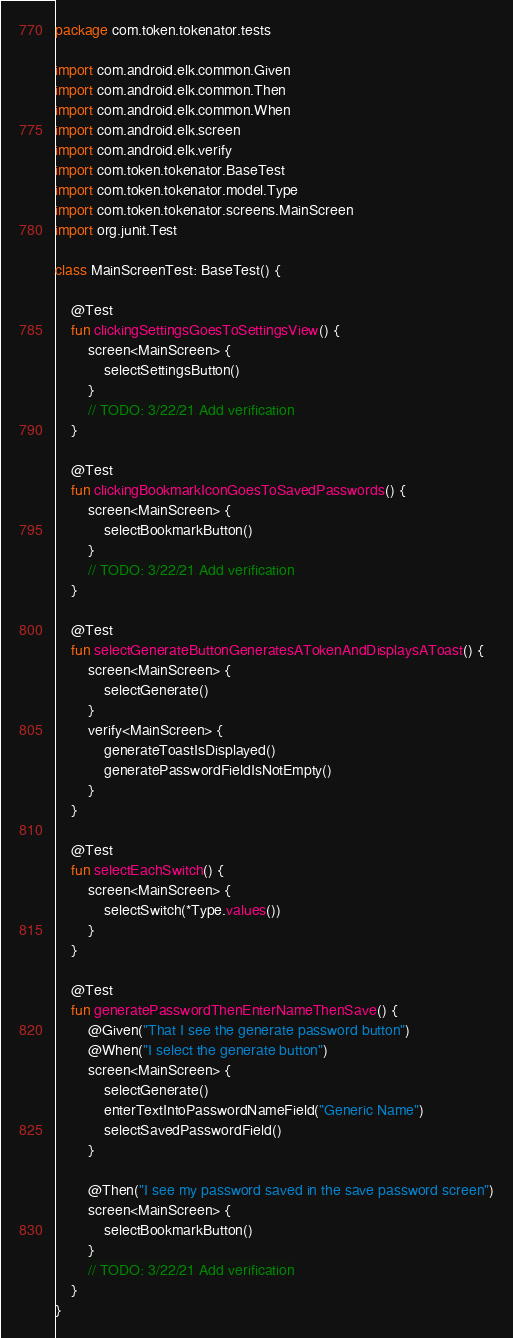Convert code to text. <code><loc_0><loc_0><loc_500><loc_500><_Kotlin_>package com.token.tokenator.tests

import com.android.elk.common.Given
import com.android.elk.common.Then
import com.android.elk.common.When
import com.android.elk.screen
import com.android.elk.verify
import com.token.tokenator.BaseTest
import com.token.tokenator.model.Type
import com.token.tokenator.screens.MainScreen
import org.junit.Test

class MainScreenTest: BaseTest() {

    @Test
    fun clickingSettingsGoesToSettingsView() {
        screen<MainScreen> {
            selectSettingsButton()
        }
        // TODO: 3/22/21 Add verification
    }

    @Test
    fun clickingBookmarkIconGoesToSavedPasswords() {
        screen<MainScreen> {
            selectBookmarkButton()
        }
        // TODO: 3/22/21 Add verification
    }

    @Test
    fun selectGenerateButtonGeneratesATokenAndDisplaysAToast() {
        screen<MainScreen> {
            selectGenerate()
        }
        verify<MainScreen> {
            generateToastIsDisplayed()
            generatePasswordFieldIsNotEmpty()
        }
    }

    @Test
    fun selectEachSwitch() {
        screen<MainScreen> {
            selectSwitch(*Type.values())
        }
    }

    @Test
    fun generatePasswordThenEnterNameThenSave() {
        @Given("That I see the generate password button")
        @When("I select the generate button")
        screen<MainScreen> {
            selectGenerate()
            enterTextIntoPasswordNameField("Generic Name")
            selectSavedPasswordField()
        }

        @Then("I see my password saved in the save password screen")
        screen<MainScreen> {
            selectBookmarkButton()
        }
        // TODO: 3/22/21 Add verification
    }
}
</code> 